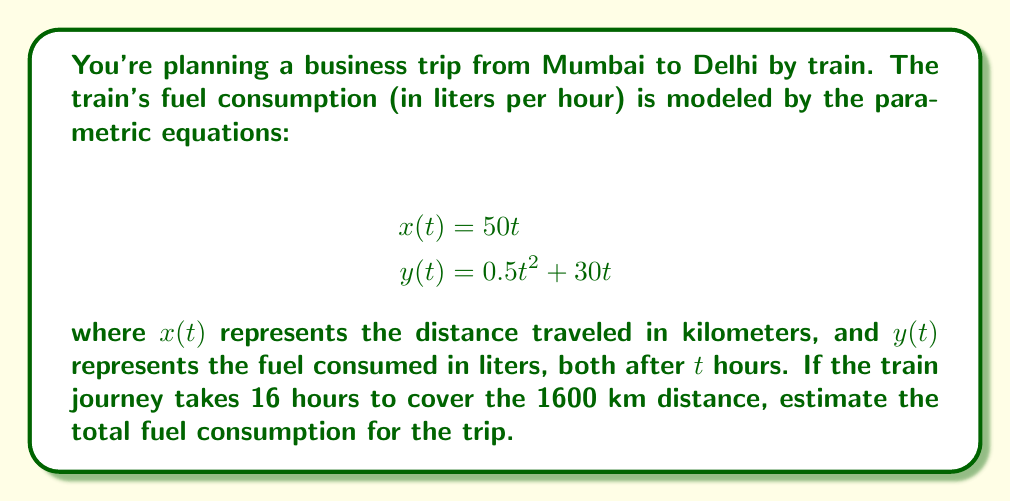Show me your answer to this math problem. Let's approach this problem step by step:

1) First, we need to find the value of $t$ when the train reaches Delhi. We know that the distance is 1600 km and it takes 16 hours. We can verify this using the $x(t)$ equation:

   $$x(16) = 50(16) = 800 \text{ km}$$

   This confirms that $t = 16$ hours is correct.

2) Now, to find the total fuel consumption, we need to calculate $y(16)$:

   $$y(16) = 0.5(16)^2 + 30(16)$$

3) Let's break this down:
   
   $$y(16) = 0.5(256) + 480$$
   $$y(16) = 128 + 480$$
   $$y(16) = 608$$

4) Therefore, the total fuel consumption for the 16-hour journey is 608 liters.

5) We can also interpret these equations parametrically:
   - The train travels at a constant speed of 50 km/h (from $x(t) = 50t$)
   - The fuel consumption has two components:
     - A quadratic term $0.5t^2$ which might represent increased fuel use at higher speeds
     - A linear term $30t$ which could represent base fuel consumption

This parametric model allows us to estimate fuel consumption for any duration of the journey, making it useful for planning various business trips by train.
Answer: The estimated total fuel consumption for the 16-hour train journey from Mumbai to Delhi is 608 liters. 